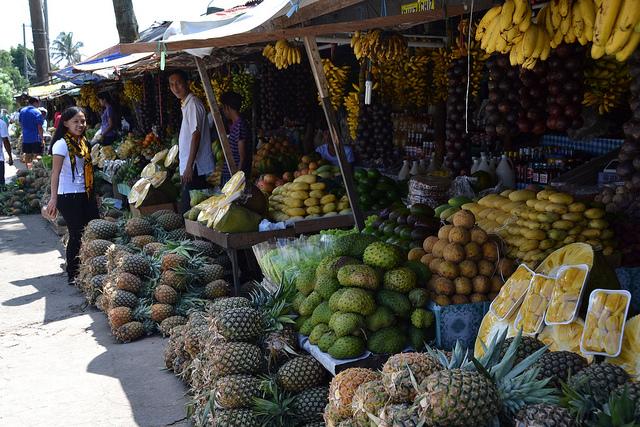What are the fruits behind the pineapples called?
Answer briefly. Jackfruit. How many people are looking toward the camera?
Concise answer only. 2. What is the color of the bananas?
Answer briefly. Yellow. 